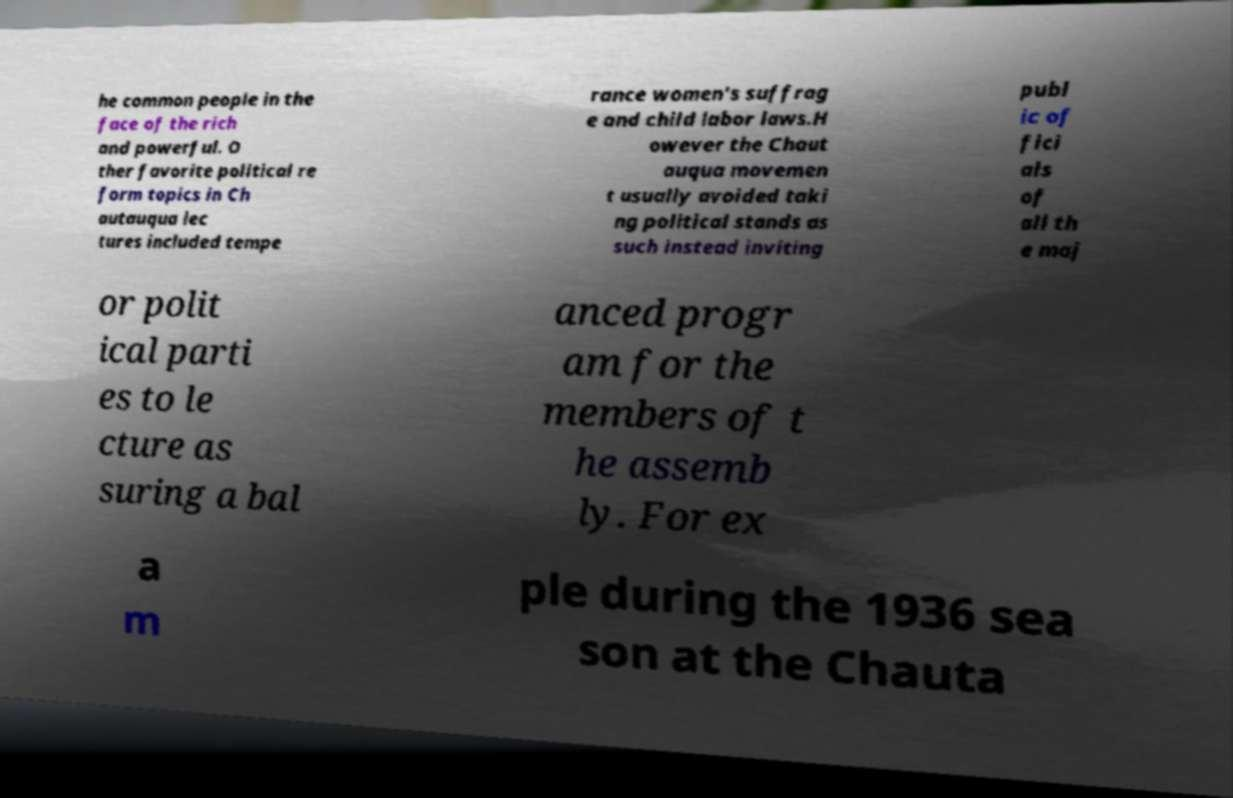There's text embedded in this image that I need extracted. Can you transcribe it verbatim? he common people in the face of the rich and powerful. O ther favorite political re form topics in Ch autauqua lec tures included tempe rance women's suffrag e and child labor laws.H owever the Chaut auqua movemen t usually avoided taki ng political stands as such instead inviting publ ic of fici als of all th e maj or polit ical parti es to le cture as suring a bal anced progr am for the members of t he assemb ly. For ex a m ple during the 1936 sea son at the Chauta 